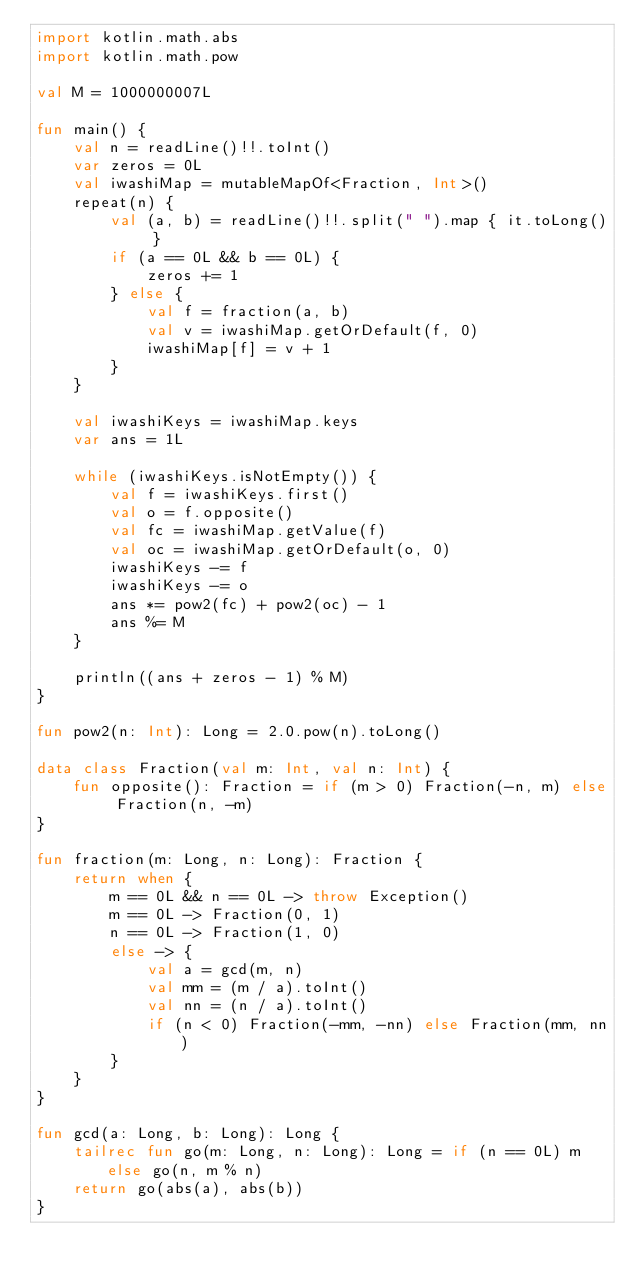Convert code to text. <code><loc_0><loc_0><loc_500><loc_500><_Kotlin_>import kotlin.math.abs
import kotlin.math.pow

val M = 1000000007L

fun main() {
    val n = readLine()!!.toInt()
    var zeros = 0L
    val iwashiMap = mutableMapOf<Fraction, Int>()
    repeat(n) {
        val (a, b) = readLine()!!.split(" ").map { it.toLong() }
        if (a == 0L && b == 0L) {
            zeros += 1
        } else {
            val f = fraction(a, b)
            val v = iwashiMap.getOrDefault(f, 0)
            iwashiMap[f] = v + 1
        }
    }

    val iwashiKeys = iwashiMap.keys
    var ans = 1L

    while (iwashiKeys.isNotEmpty()) {
        val f = iwashiKeys.first()
        val o = f.opposite()
        val fc = iwashiMap.getValue(f)
        val oc = iwashiMap.getOrDefault(o, 0)
        iwashiKeys -= f
        iwashiKeys -= o
        ans *= pow2(fc) + pow2(oc) - 1
        ans %= M
    }

    println((ans + zeros - 1) % M)
}

fun pow2(n: Int): Long = 2.0.pow(n).toLong()

data class Fraction(val m: Int, val n: Int) {
    fun opposite(): Fraction = if (m > 0) Fraction(-n, m) else Fraction(n, -m)
}

fun fraction(m: Long, n: Long): Fraction {
    return when {
        m == 0L && n == 0L -> throw Exception()
        m == 0L -> Fraction(0, 1)
        n == 0L -> Fraction(1, 0)
        else -> {
            val a = gcd(m, n)
            val mm = (m / a).toInt()
            val nn = (n / a).toInt()
            if (n < 0) Fraction(-mm, -nn) else Fraction(mm, nn)
        }
    }
}

fun gcd(a: Long, b: Long): Long {
    tailrec fun go(m: Long, n: Long): Long = if (n == 0L) m else go(n, m % n)
    return go(abs(a), abs(b))
}
</code> 